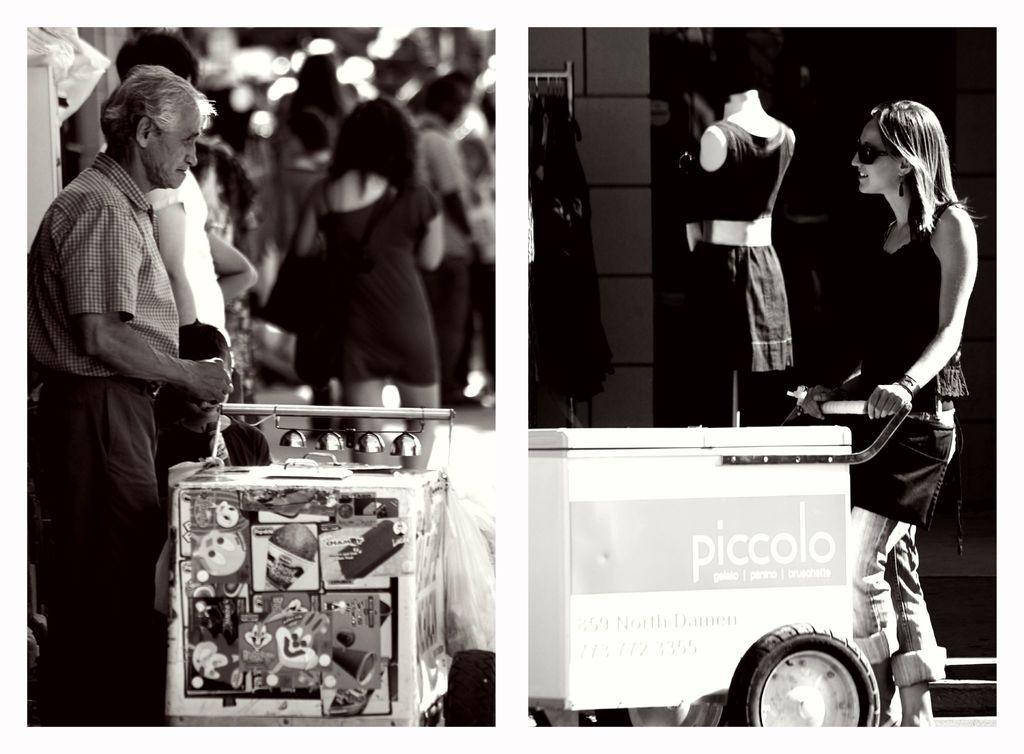In one or two sentences, can you explain what this image depicts? It is a black and white collage image, in the first image there is an old man and in front of him there is an ice cream vehicle, behind him there are few other people and on the right side there is a woman and in front of the women there is a small vehicle, behind her there is a mannequin and clothes. 